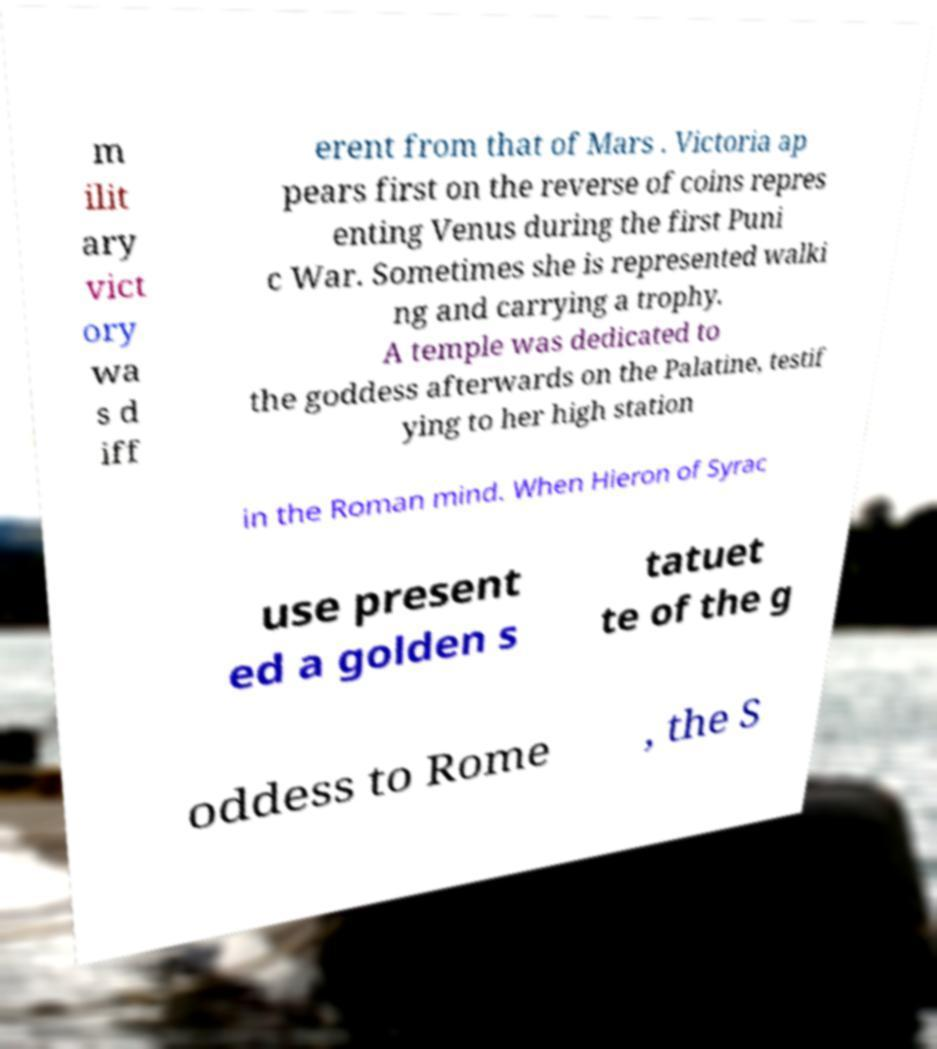I need the written content from this picture converted into text. Can you do that? m ilit ary vict ory wa s d iff erent from that of Mars . Victoria ap pears first on the reverse of coins repres enting Venus during the first Puni c War. Sometimes she is represented walki ng and carrying a trophy. A temple was dedicated to the goddess afterwards on the Palatine, testif ying to her high station in the Roman mind. When Hieron of Syrac use present ed a golden s tatuet te of the g oddess to Rome , the S 